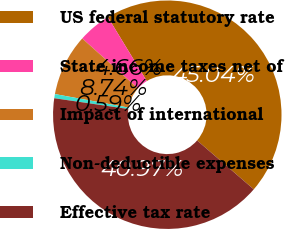Convert chart to OTSL. <chart><loc_0><loc_0><loc_500><loc_500><pie_chart><fcel>US federal statutory rate<fcel>State income taxes net of<fcel>Impact of international<fcel>Non-deductible expenses<fcel>Effective tax rate<nl><fcel>45.04%<fcel>4.66%<fcel>8.74%<fcel>0.59%<fcel>40.97%<nl></chart> 